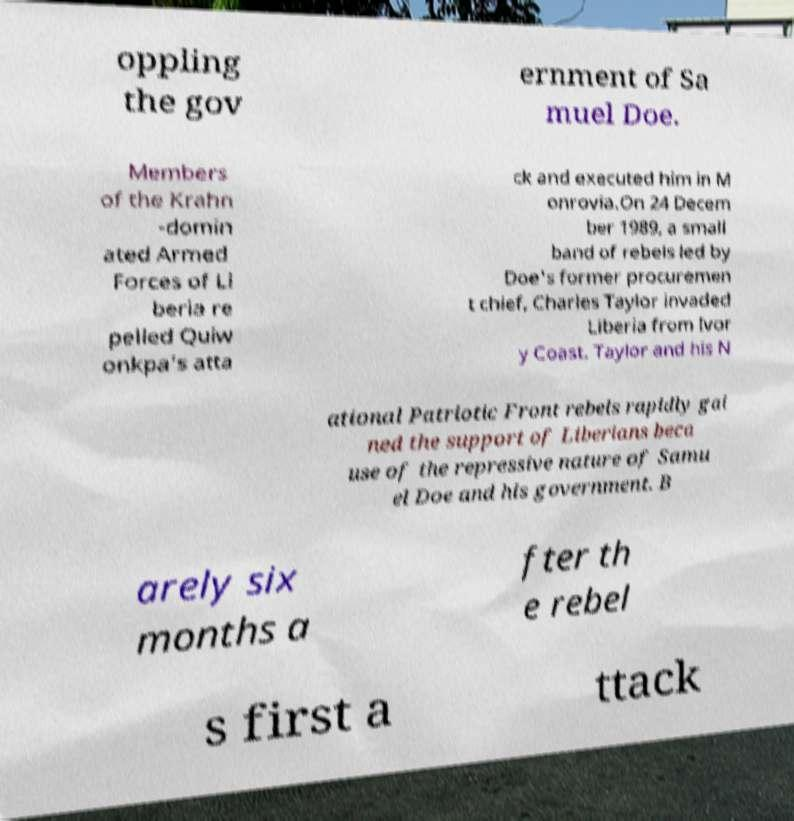Can you accurately transcribe the text from the provided image for me? oppling the gov ernment of Sa muel Doe. Members of the Krahn -domin ated Armed Forces of Li beria re pelled Quiw onkpa's atta ck and executed him in M onrovia.On 24 Decem ber 1989, a small band of rebels led by Doe's former procuremen t chief, Charles Taylor invaded Liberia from Ivor y Coast. Taylor and his N ational Patriotic Front rebels rapidly gai ned the support of Liberians beca use of the repressive nature of Samu el Doe and his government. B arely six months a fter th e rebel s first a ttack 